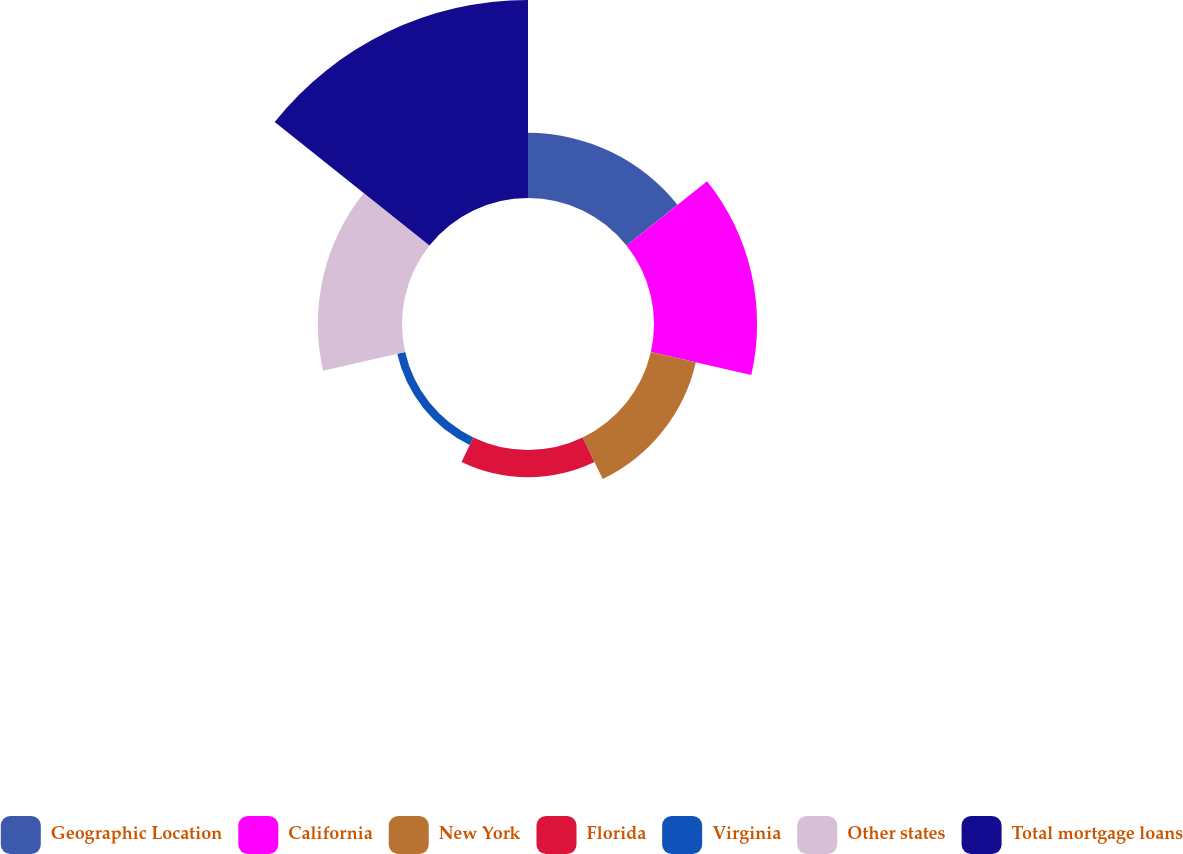Convert chart. <chart><loc_0><loc_0><loc_500><loc_500><pie_chart><fcel>Geographic Location<fcel>California<fcel>New York<fcel>Florida<fcel>Virginia<fcel>Other states<fcel>Total mortgage loans<nl><fcel>12.25%<fcel>19.38%<fcel>8.68%<fcel>5.11%<fcel>1.54%<fcel>15.82%<fcel>37.23%<nl></chart> 